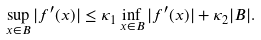<formula> <loc_0><loc_0><loc_500><loc_500>\sup _ { x \in B } | f ^ { \prime } ( x ) | \leq \kappa _ { 1 } \inf _ { x \in B } | f ^ { \prime } ( x ) | + \kappa _ { 2 } | B | .</formula> 